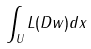Convert formula to latex. <formula><loc_0><loc_0><loc_500><loc_500>\int _ { U } L ( D w ) d x</formula> 